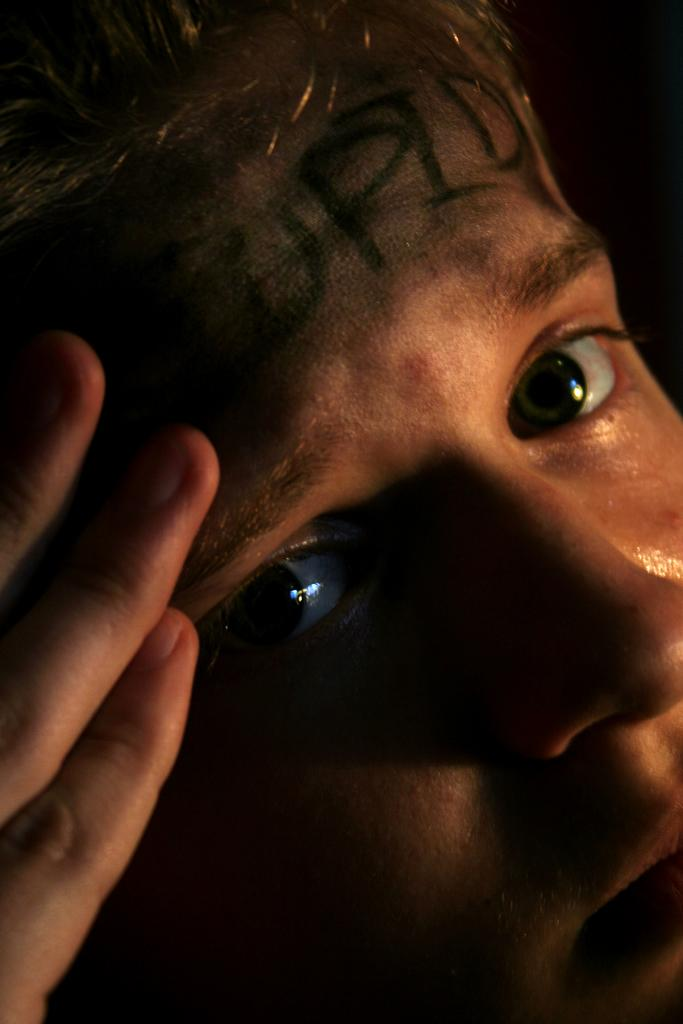What is the main subject of the image? There is a person in the image. Can you describe any unique features of the person? There are letters written on the person's head. What is the taste of the train in the image? There is no train present in the image, so it is not possible to determine its taste. 